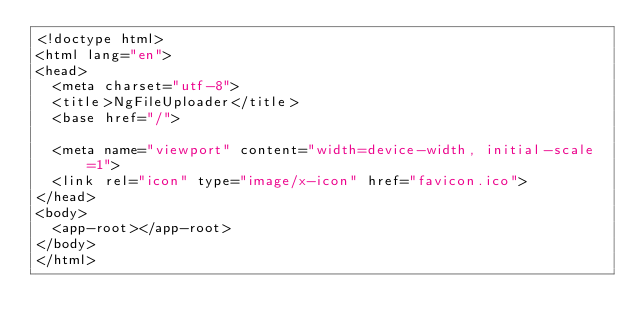Convert code to text. <code><loc_0><loc_0><loc_500><loc_500><_HTML_><!doctype html>
<html lang="en">
<head>
  <meta charset="utf-8">
  <title>NgFileUploader</title>
  <base href="/">

  <meta name="viewport" content="width=device-width, initial-scale=1">
  <link rel="icon" type="image/x-icon" href="favicon.ico">
</head>
<body>
  <app-root></app-root>
</body>
</html>
</code> 